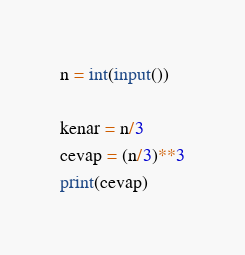<code> <loc_0><loc_0><loc_500><loc_500><_Python_>n = int(input())

kenar = n/3
cevap = (n/3)**3
print(cevap)</code> 